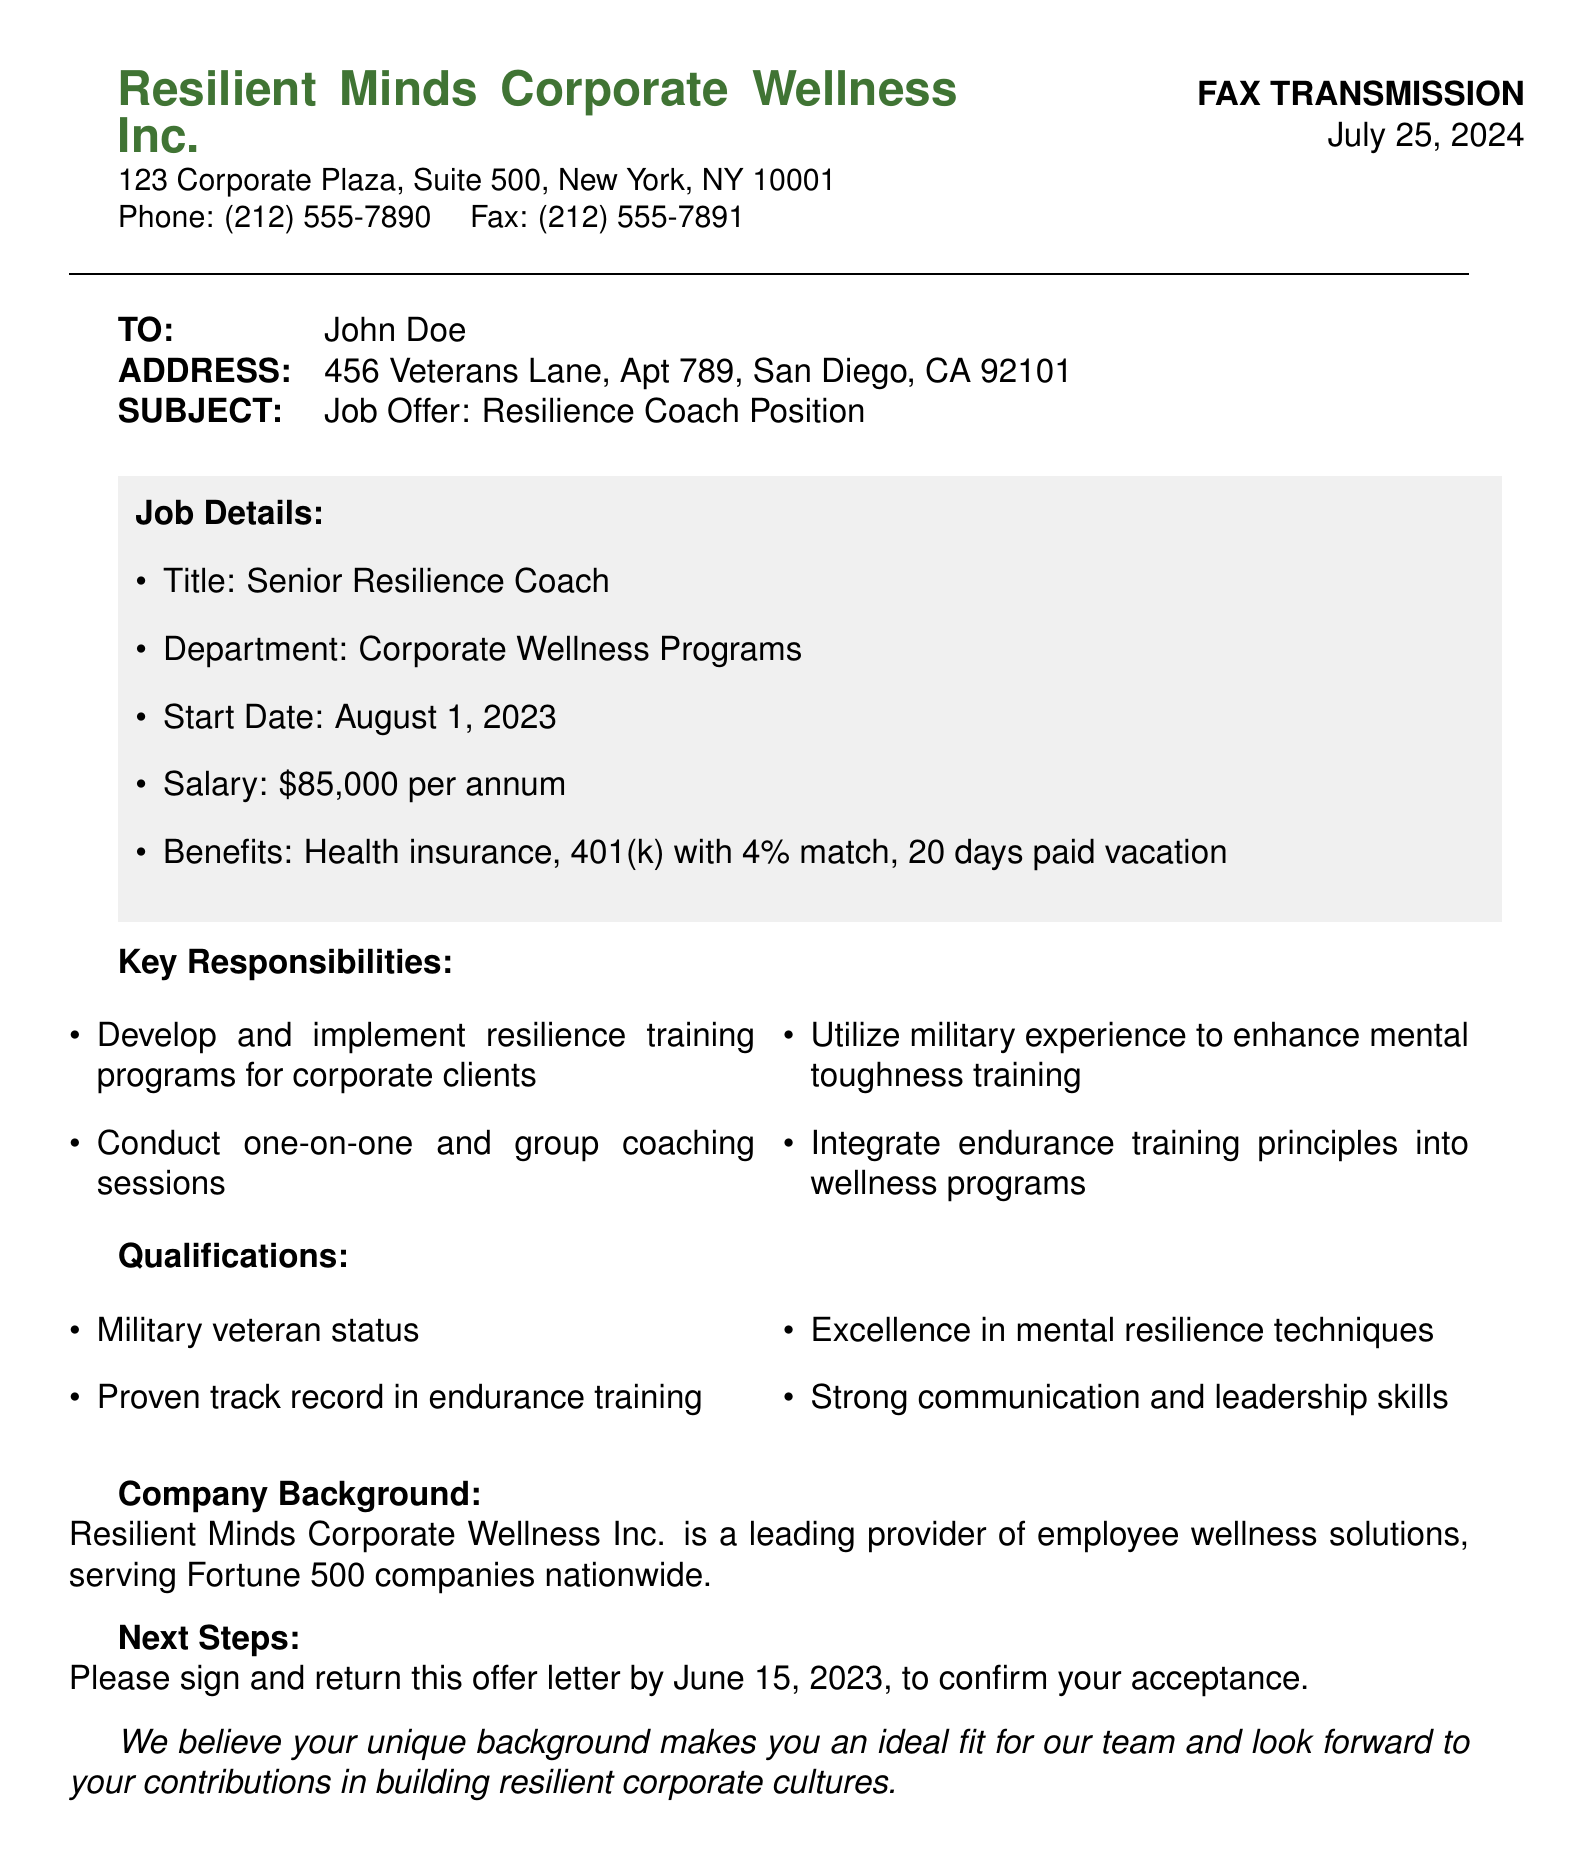What is the name of the company? The name of the company is stated at the top of the document.
Answer: Resilient Minds Corporate Wellness Inc What is the job title offered? The job title is mentioned in the subject line and job details section.
Answer: Senior Resilience Coach What is the salary for the position? The salary information is provided under job details.
Answer: $85,000 per annum What is the start date for the job? The start date can be found in the job details section.
Answer: August 1, 2023 What are the benefits included with the position? The benefits are listed in the job details section.
Answer: Health insurance, 401(k) with 4% match, 20 days paid vacation What qualifies someone for the position? The qualifications are itemized in the document.
Answer: Military veteran status, Proven track record in endurance training, Excellence in mental resilience techniques, Strong communication and leadership skills What should the recipient do to accept the offer? The next steps section outlines what is required for acceptance.
Answer: Sign and return this offer letter by June 15, 2023 What is the significance of military experience in this role? The document highlights the integration of military experience into training programs.
Answer: Enhance mental toughness training What is the company's focus area? The background section describes the company's area of expertise.
Answer: Employee wellness solutions When is the deadline to return the offer letter? The deadline is specified in the next steps section.
Answer: June 15, 2023 